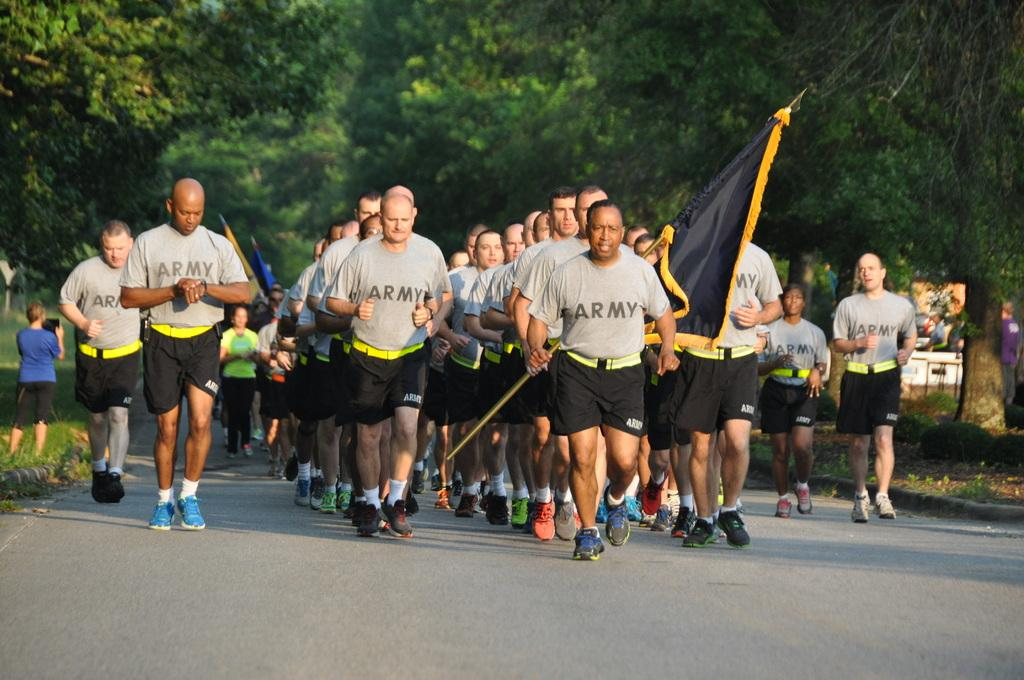What is happening on the road in the image? There is a group of people on the road in the image. What can be seen in addition to the people on the road? There are flags visible in the image. Can you describe any objects present in the image? There are some objects present in the image, but their specific nature is not mentioned in the facts. What is visible in the background of the image? There are trees in the background of the image. What type of pocket is visible on the fowl in the image? There is no fowl present in the image, so there is no pocket to be seen. 